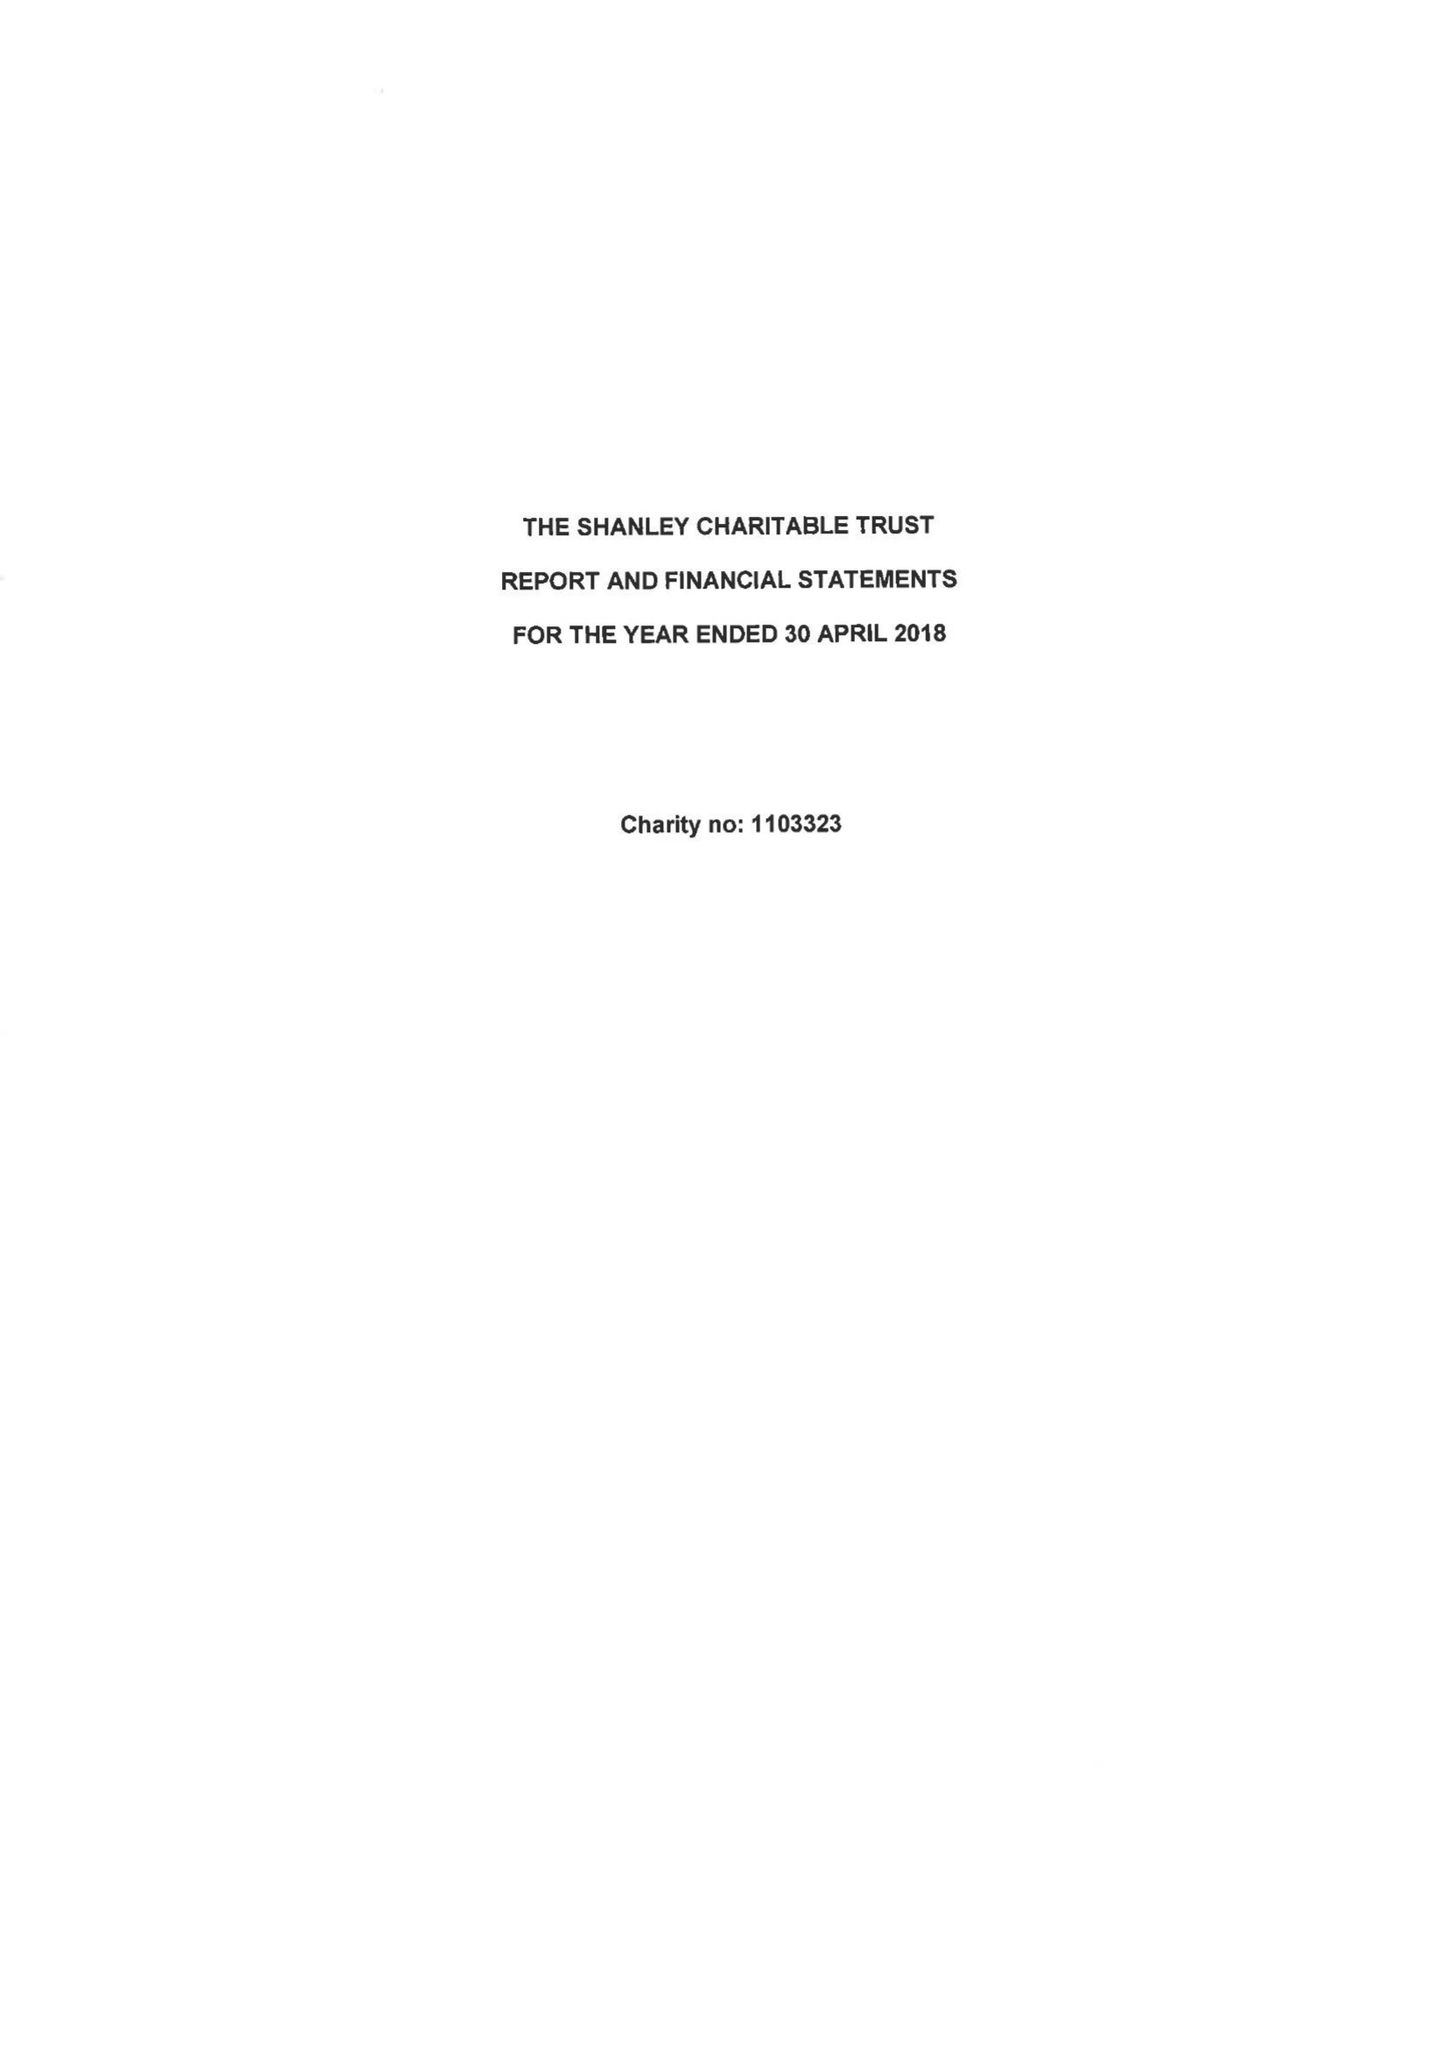What is the value for the charity_number?
Answer the question using a single word or phrase. 1103323 